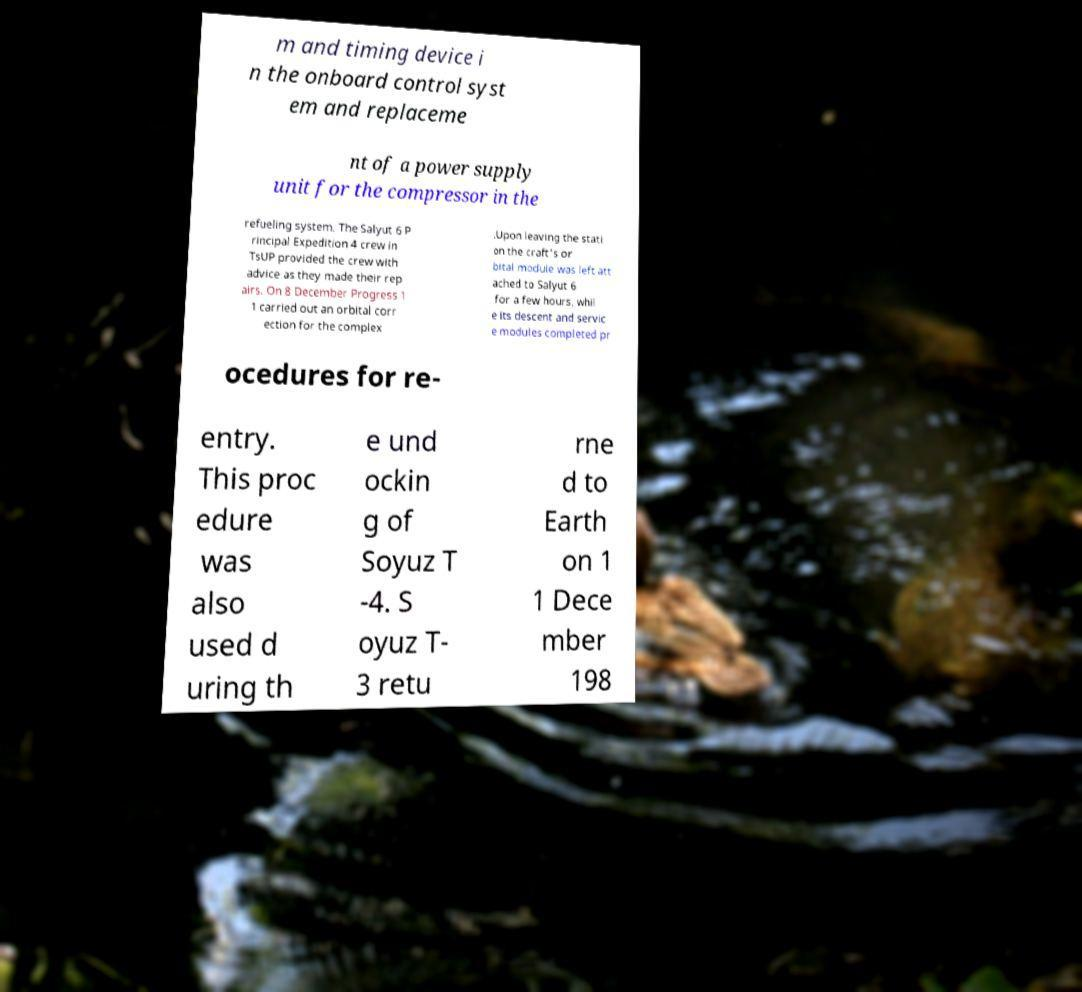Could you extract and type out the text from this image? m and timing device i n the onboard control syst em and replaceme nt of a power supply unit for the compressor in the refueling system. The Salyut 6 P rincipal Expedition 4 crew in TsUP provided the crew with advice as they made their rep airs. On 8 December Progress 1 1 carried out an orbital corr ection for the complex .Upon leaving the stati on the craft's or bital module was left att ached to Salyut 6 for a few hours, whil e its descent and servic e modules completed pr ocedures for re- entry. This proc edure was also used d uring th e und ockin g of Soyuz T -4. S oyuz T- 3 retu rne d to Earth on 1 1 Dece mber 198 